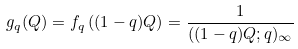Convert formula to latex. <formula><loc_0><loc_0><loc_500><loc_500>g _ { q } ( Q ) = f _ { q } \left ( ( 1 - q ) Q \right ) = \frac { 1 } { ( ( 1 - q ) Q ; q ) _ { \infty } }</formula> 